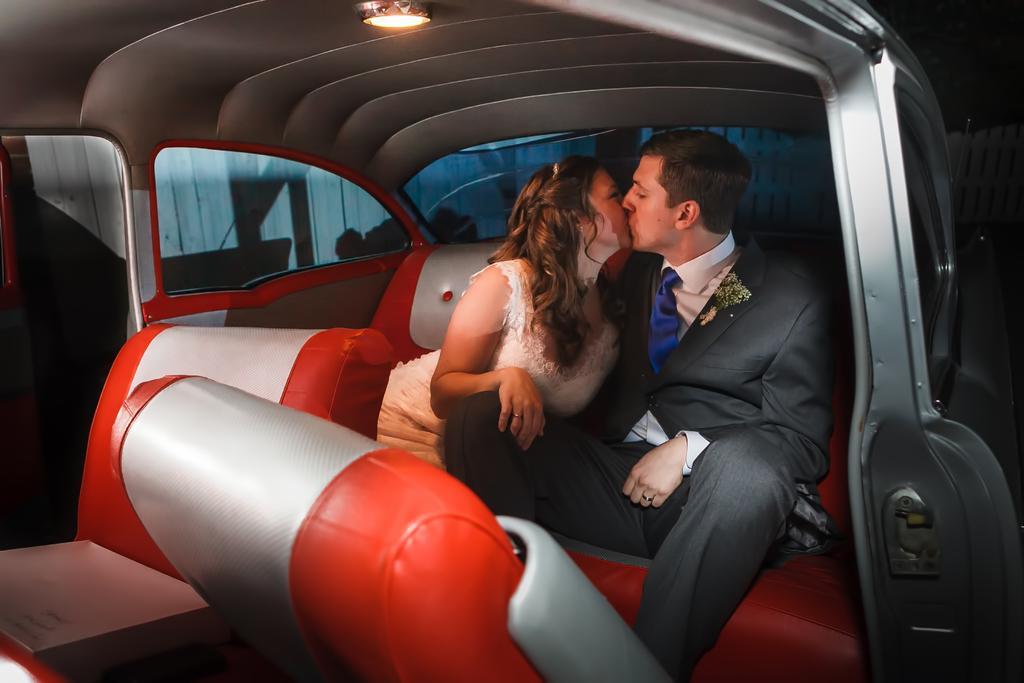Can you describe this image briefly? This image is taken inside a car. There are two persons in this car a woman and a man. In the left side of the image there is a front seat of a car. At the top of the image there is a roof and a light. 